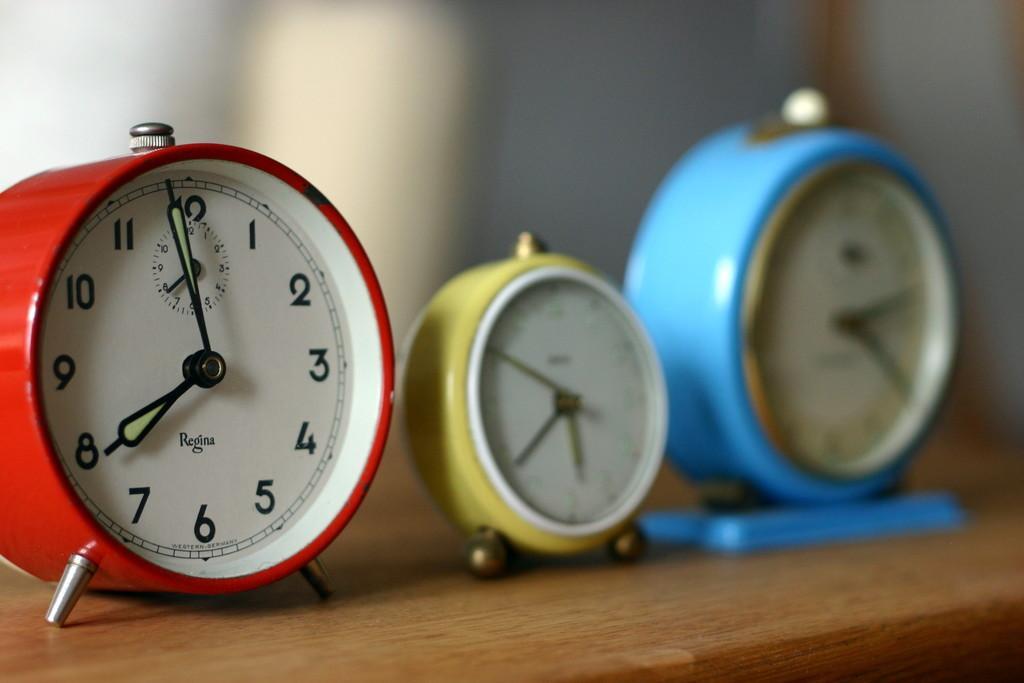In one or two sentences, can you explain what this image depicts? In the image there are three table clocks on a wooden table. 